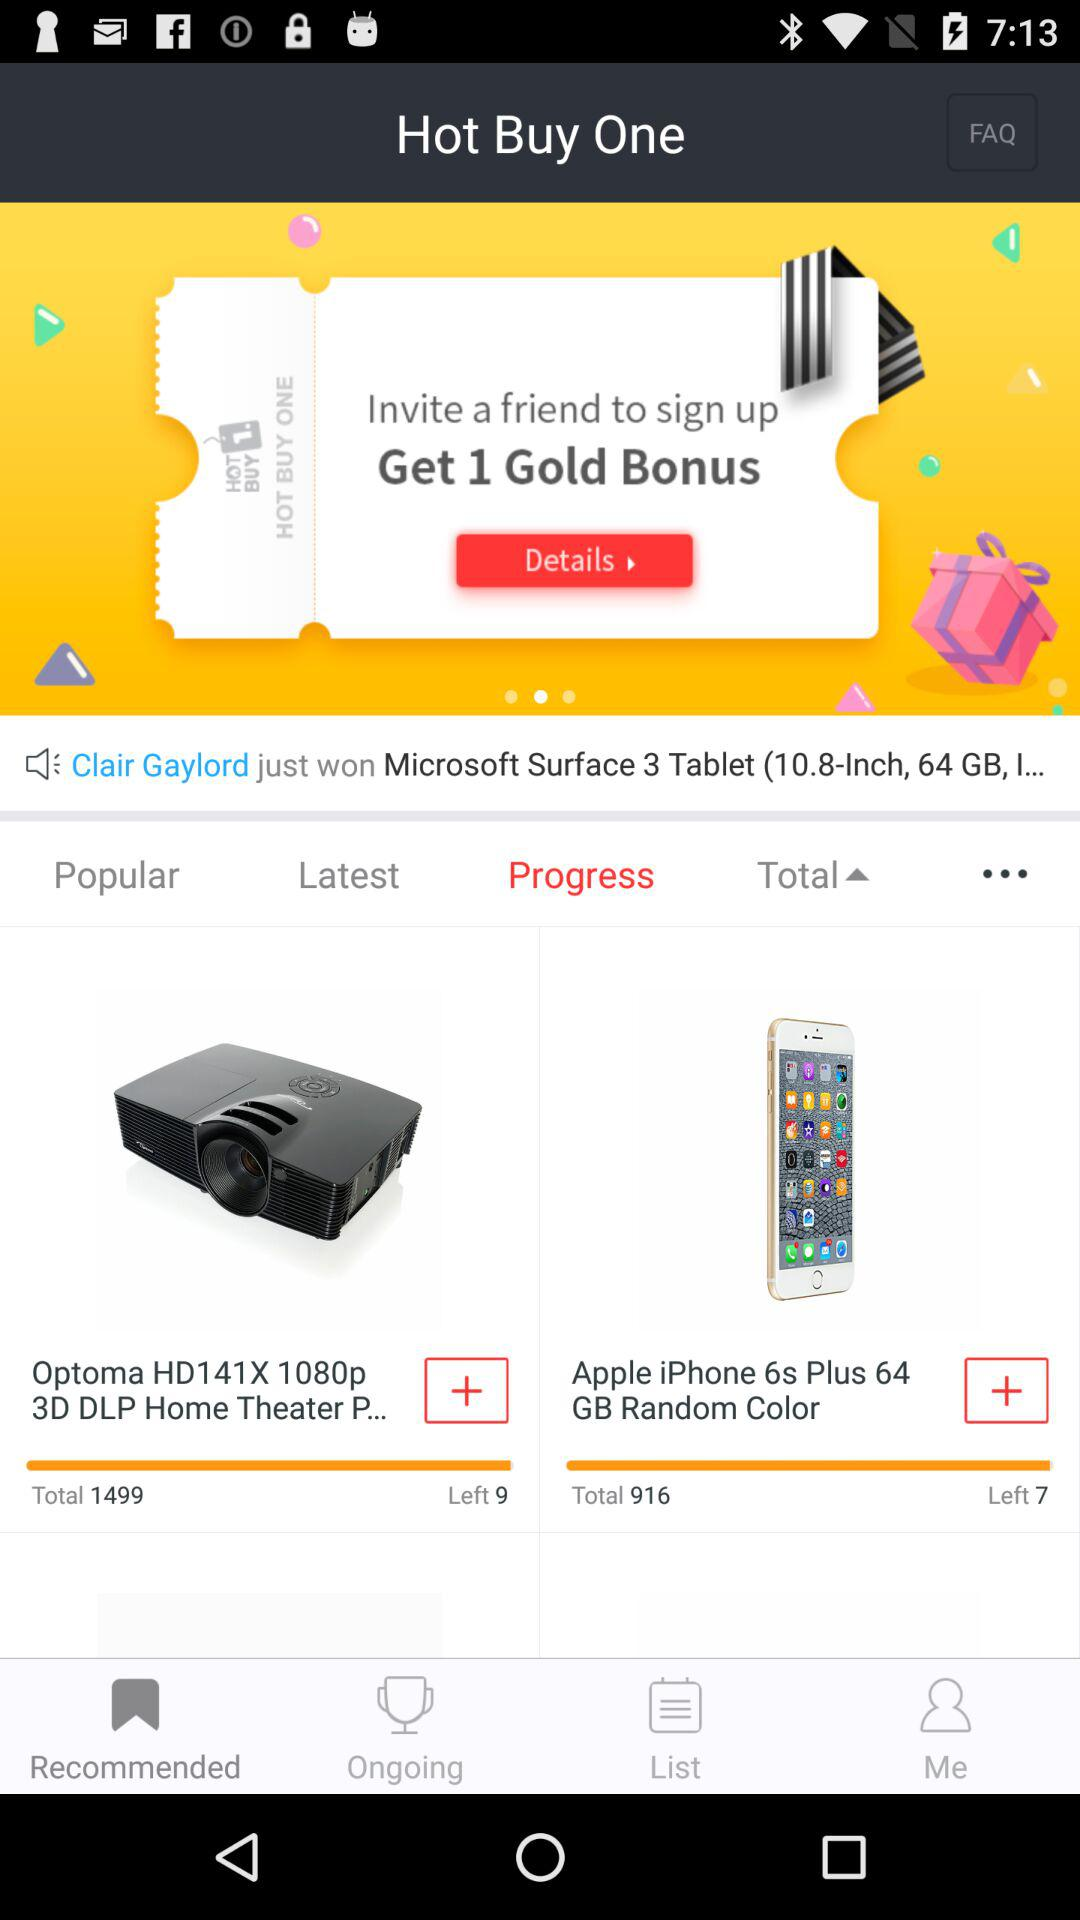Who won the "Microsoft Surface 3 Tablet"? The "Microsoft Surface 3 Tablet" was won by Clair Gaylord. 